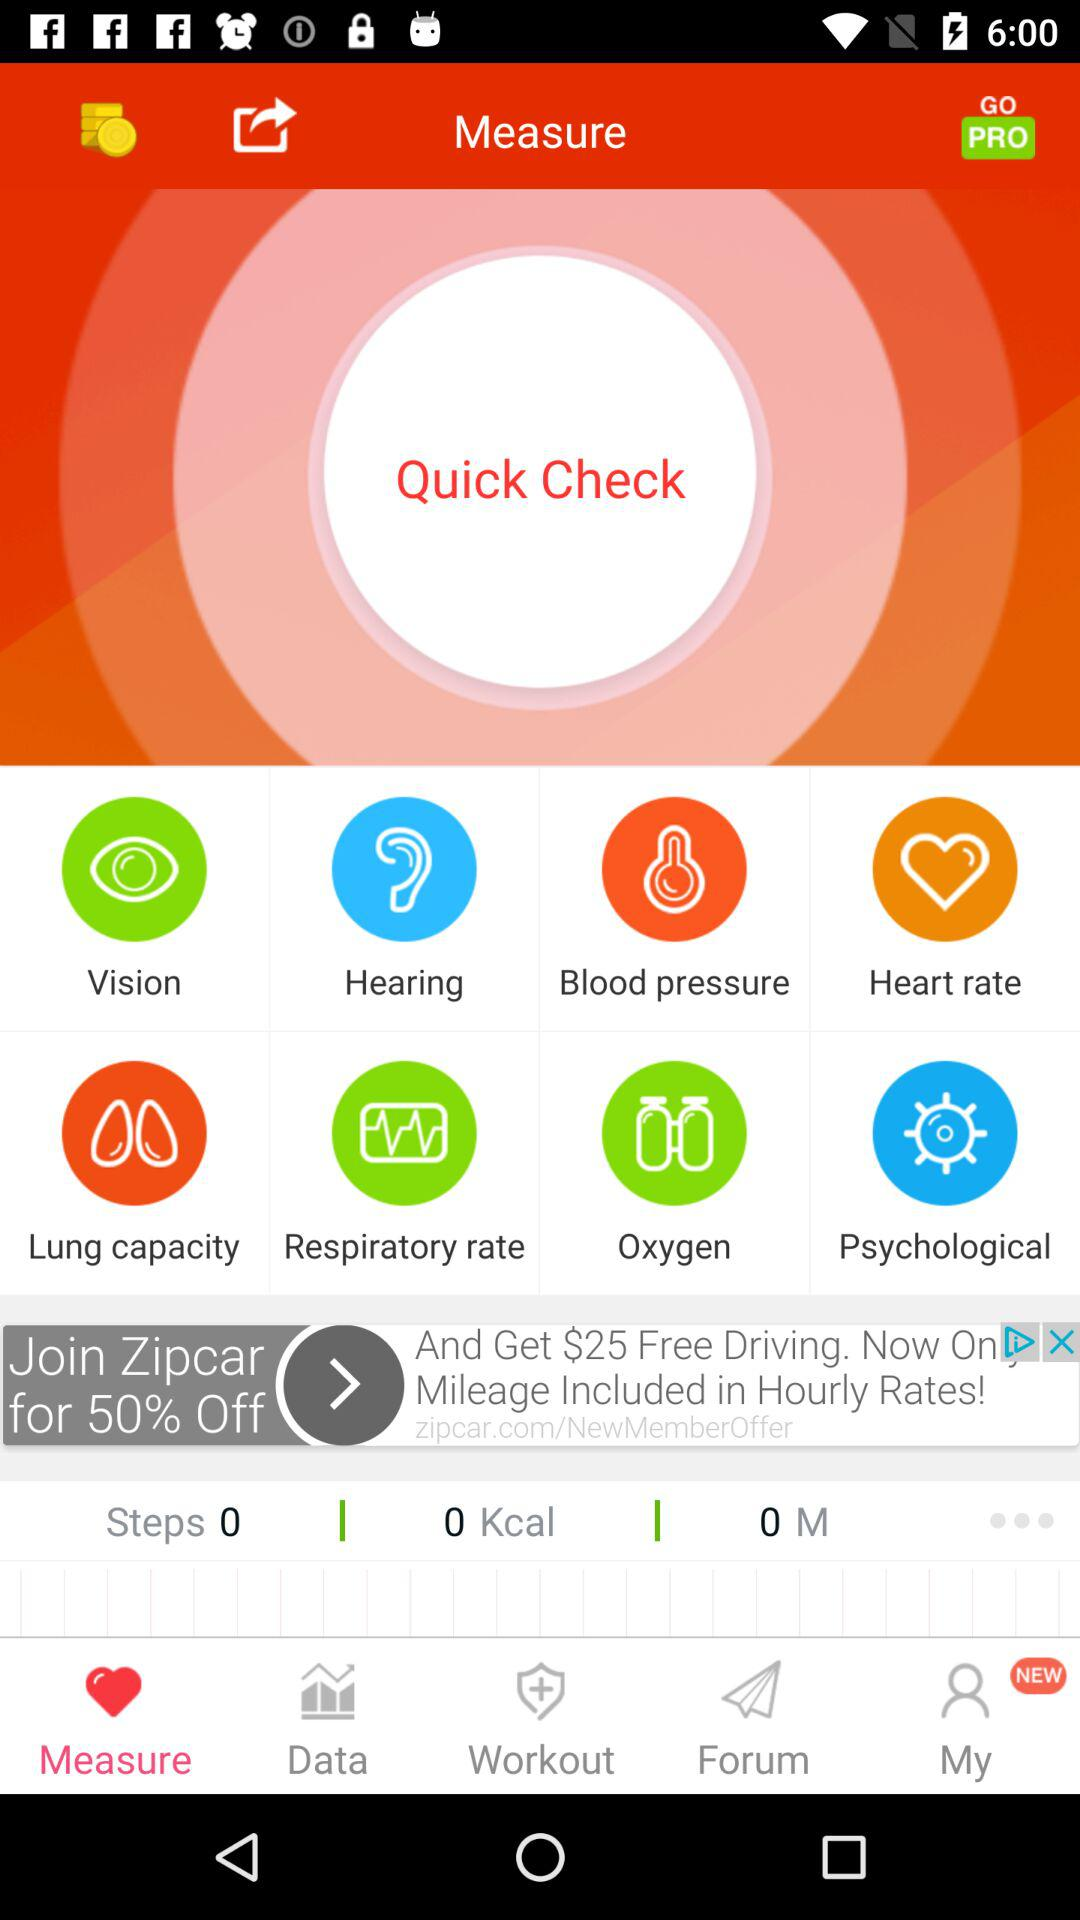How many calories have been burned? The number of burned calories is 0. 